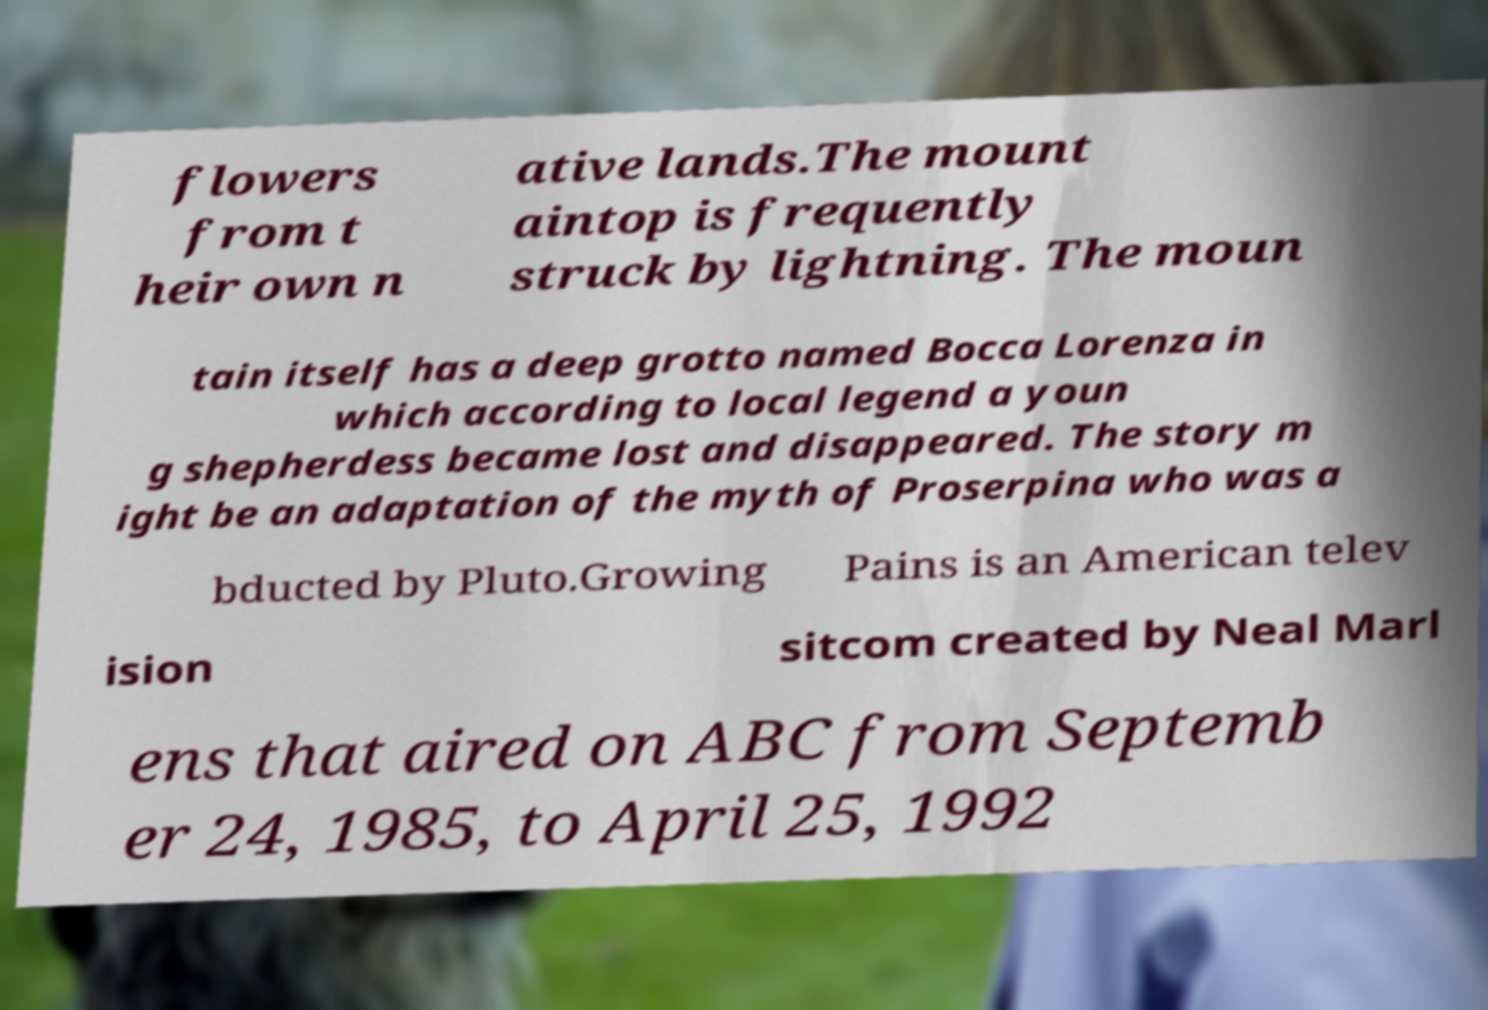Please identify and transcribe the text found in this image. flowers from t heir own n ative lands.The mount aintop is frequently struck by lightning. The moun tain itself has a deep grotto named Bocca Lorenza in which according to local legend a youn g shepherdess became lost and disappeared. The story m ight be an adaptation of the myth of Proserpina who was a bducted by Pluto.Growing Pains is an American telev ision sitcom created by Neal Marl ens that aired on ABC from Septemb er 24, 1985, to April 25, 1992 